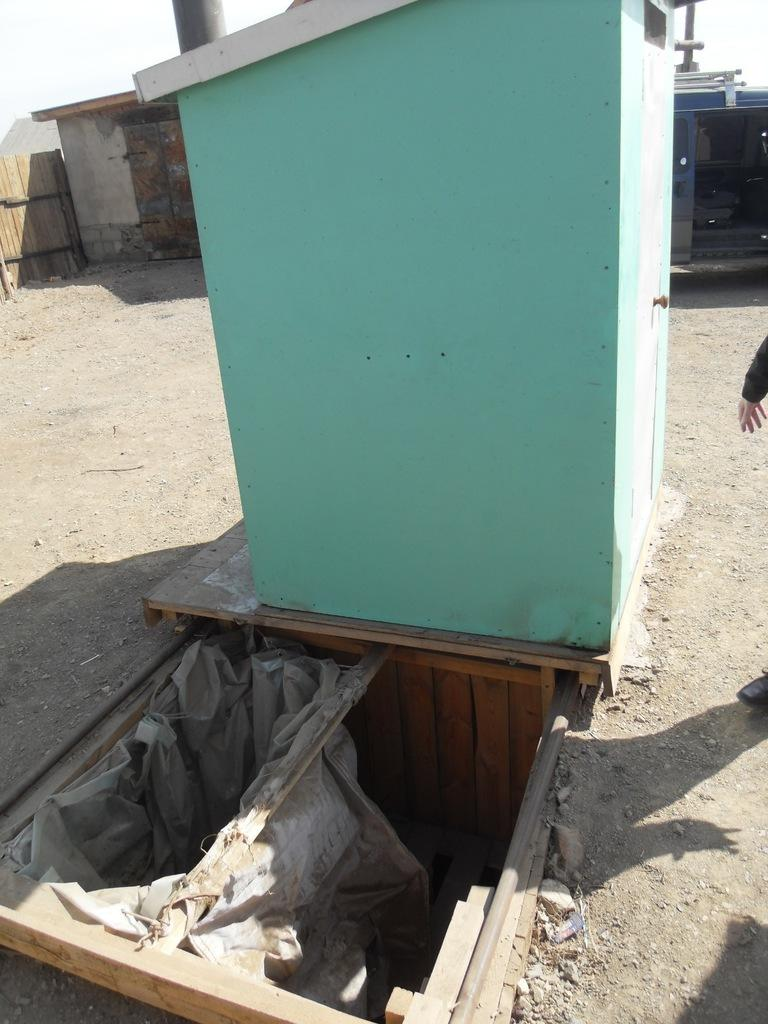What type of structure is in the image? There is a cabin in the image. What can be seen at the bottom of the image? There are wooden sticks at the bottom of the image. Is there a person in the image? Yes, there is a person standing on the ground to the right of the cabin. What is visible at the top of the image? The sky is visible at the top of the image. How many clovers are growing near the cabin in the image? There is no mention of clovers in the image, so it is impossible to determine their presence or quantity. What type of bed is inside the cabin in the image? There is no information about a bed inside the cabin, as the image only shows the exterior of the structure. 